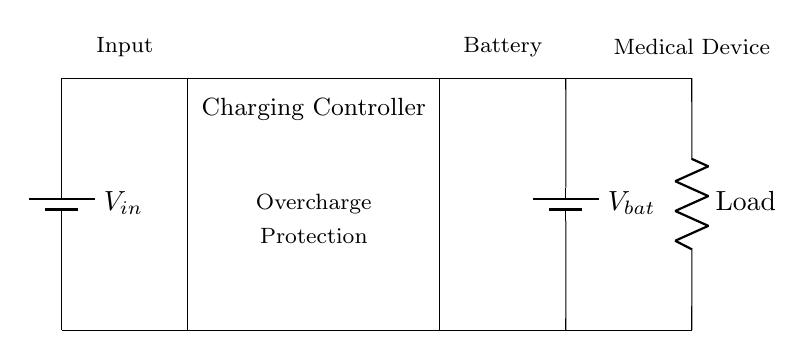What is the input voltage in the circuit? The input voltage is denoted as V_in, which is represented by the battery symbol at the top left of the diagram. This is the voltage supplied to the charging controller.
Answer: V_in What is the function of the rectangle labeled "Charging Controller"? The rectangle labeled "Charging Controller" indicates that this component manages the charging process of the battery. It is responsible for ensuring the battery charges correctly and includes overcharge protection to prevent damaging the battery.
Answer: Charging management Which component provides overcharge protection? The "Charging Controller" is the component responsible for overcharge protection, as indicated in the label within the rectangle. It prevents the battery from being charged beyond its capacity ensures safety in the charging process.
Answer: Charging Controller What connects the input voltage to the charging controller? The input voltage is connected to the charging controller through a direct wire connection that runs from the battery symbol of V_in to the left side of the rectangle. This connection allows the voltage to flow into the charging circuit.
Answer: Direct wire connection How many batteries are shown in the circuit? There are two battery symbols depicted; one indicates the input voltage V_in and the other indicates the battery voltage V_bat. This shows that the circuit includes both an external power source and an internal battery to store charge.
Answer: Two batteries What does the load represent in this circuit? The load, represented by the resistor symbol on the right side of the diagram, signifies the medical device that utilizes the power provided by the battery. It is the component that consumes the stored energy from the battery once charged.
Answer: Medical device 